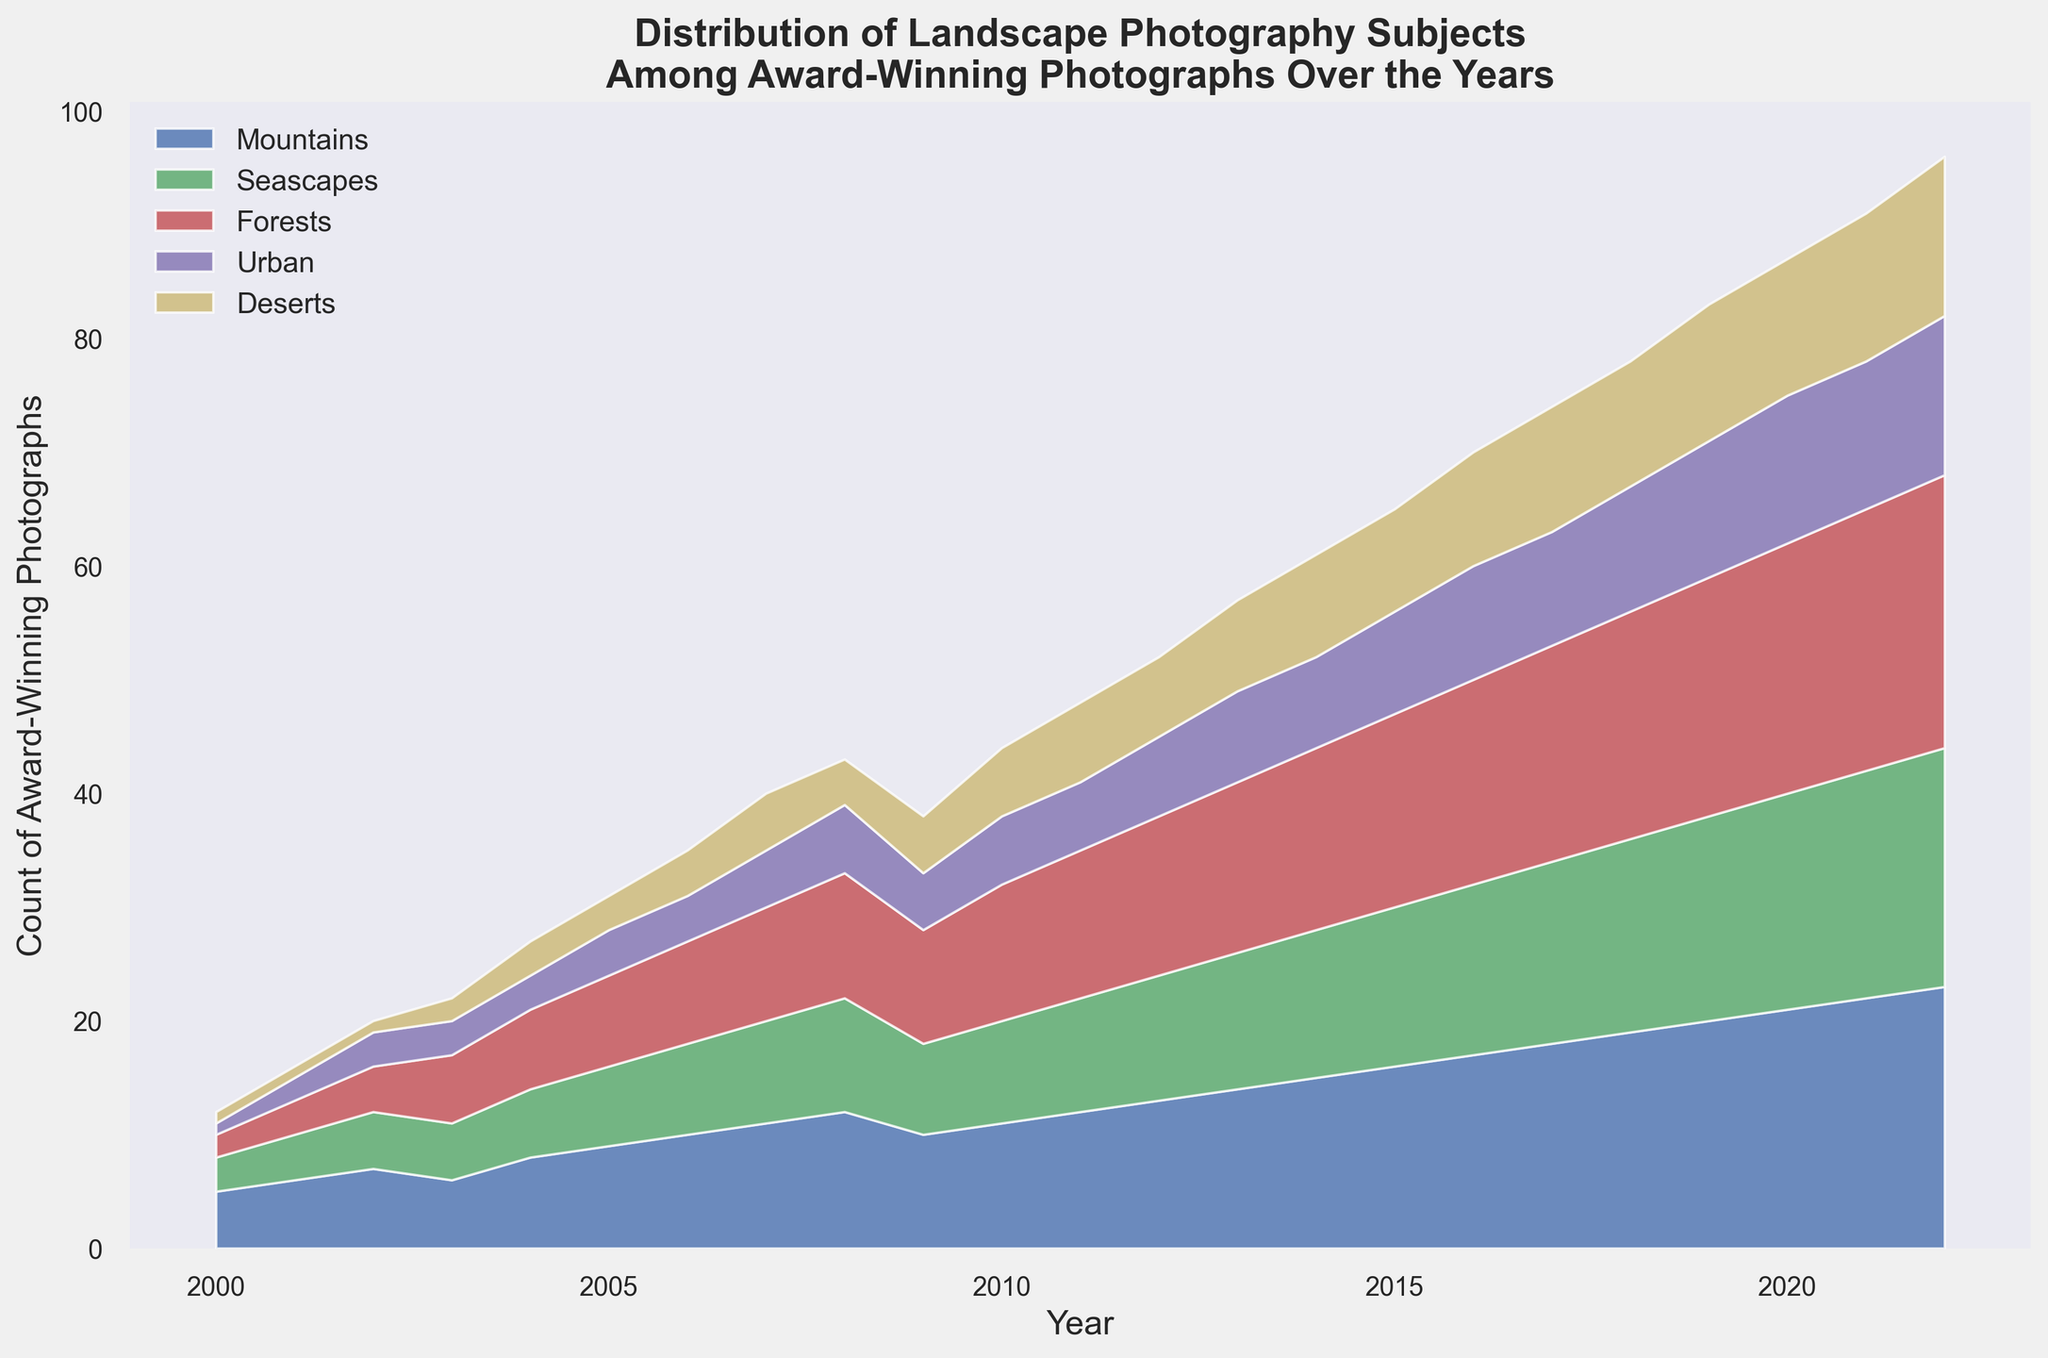What is the overall trend for the count of award-winning photographs featuring mountains from 2000 to 2022? The count of award-winning photographs featuring mountains steadily increases from 5 in 2000 to 23 in 2022.
Answer: Steady increase Which landscape subject had the most significant increase in award-winning photographs from 2000 to 2022? By examining the area chart, forests seem to have had a noticeable increase, from 2 in 2000 to 24 in 2022.
Answer: Forests Between Seascapes and Urban categories, which one saw a steadier growth in award-winning photographs over the years? Seascapes saw a more consistent year-by-year increase compared to the Urban category, which had some years with no growth.
Answer: Seascapes In the year 2010, which category had the second-highest count of award-winning photographs? In 2010, forests had the second-highest count with 12 award-winning photographs.
Answer: Forests Calculate the average number of award-winning photographs for the Deserts category over the given period. Sum the counts for Deserts from 2000 to 2022 and then divide by the number of years: (1+1+1+2+3+3+4+5+4+5+6+7+7+8+9+10+11+11+12+12+13+14)/23 = 6
Answer: 6 Which landscape subject had the lowest representation in the year 2006? In 2006, the Urban category had the lowest representation with 4 award-winning photographs.
Answer: Urban Compare the counts of award-winning photographs for Mountains and Seascapes in 2022. Which category had more? In 2022, Mountains had 23 award-winning photographs, while Seascapes had 21. Thus, Mountains had more.
Answer: Mountains How does the growth rate of award-winning photographs featuring Urban landscapes compare to those featuring Deserts from 2010 to 2022? From 2010 to 2022, Urban landscapes increased from 6 to 14 (growth of 8), while Deserts increased from 6 to 14 (growth of 8) showing equal growth rates.
Answer: Equal growth rates In what year did Forests surpass Seascapes in the count of award-winning photographs? Forests surpassed Seascapes in the year 2003. Forests had 6 award-winning photographs, and Seascapes had 5.
Answer: 2003 